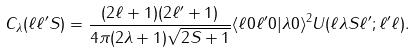<formula> <loc_0><loc_0><loc_500><loc_500>C _ { \lambda } ( \ell \ell ^ { \prime } S ) = \frac { ( 2 \ell + 1 ) ( 2 \ell ^ { \prime } + 1 ) } { 4 \pi ( 2 \lambda + 1 ) \sqrt { 2 S + 1 } } \langle \ell 0 \ell ^ { \prime } 0 | \lambda 0 \rangle ^ { 2 } U ( \ell \lambda S \ell ^ { \prime } ; \ell ^ { \prime } \ell ) .</formula> 